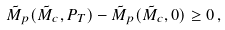Convert formula to latex. <formula><loc_0><loc_0><loc_500><loc_500>\tilde { M } _ { p } ( \tilde { M } _ { c } , P _ { T } ) - \tilde { M } _ { p } ( \tilde { M } _ { c } , 0 ) \geq 0 \, ,</formula> 